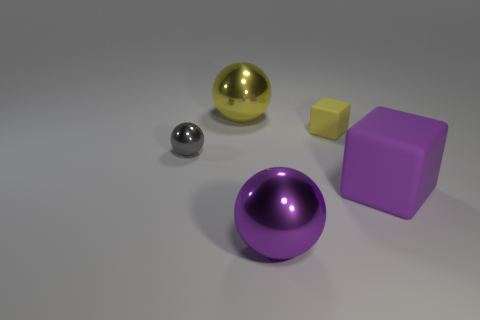There is a big rubber cube; does it have the same color as the large ball that is in front of the tiny gray thing?
Provide a short and direct response. Yes. There is a purple sphere that is the same size as the purple cube; what is its material?
Your answer should be very brief. Metal. Are there fewer tiny yellow rubber things to the right of the purple rubber block than big things that are to the right of the small metallic sphere?
Make the answer very short. Yes. There is a rubber object that is left of the big cube right of the gray metal sphere; what is its shape?
Your answer should be very brief. Cube. Is there a big red shiny thing?
Your response must be concise. No. The big object that is behind the small metal ball is what color?
Give a very brief answer. Yellow. There is a sphere that is the same color as the small matte cube; what is its material?
Offer a terse response. Metal. Are there any gray metallic things in front of the gray metal ball?
Your answer should be compact. No. Are there more small gray shiny objects than tiny green matte cylinders?
Offer a very short reply. Yes. What color is the tiny object that is on the right side of the large metal thing that is in front of the rubber object that is behind the small gray thing?
Your answer should be compact. Yellow. 